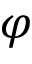<formula> <loc_0><loc_0><loc_500><loc_500>\varphi</formula> 